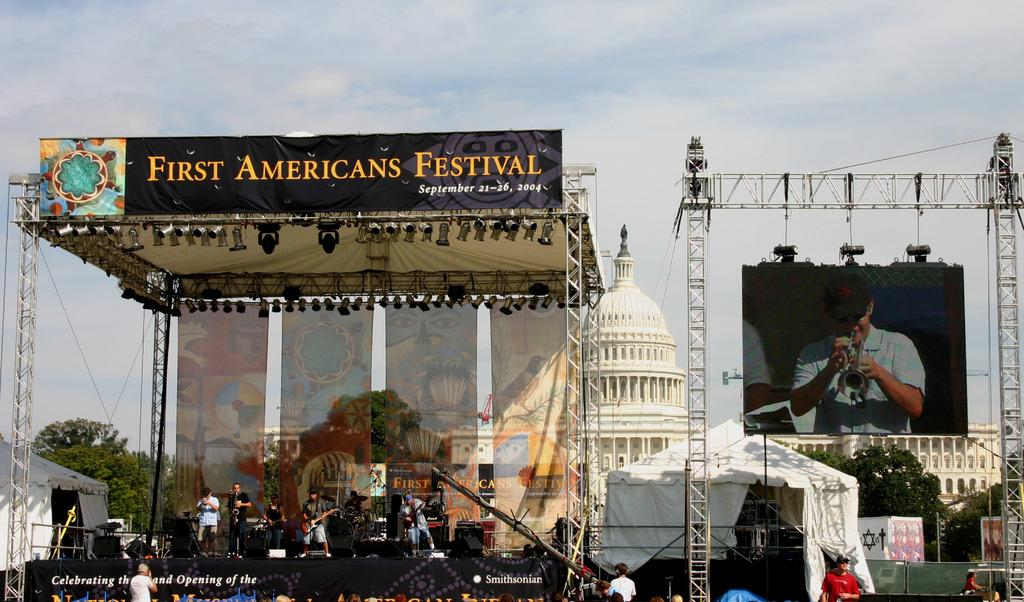<image>
Describe the image concisely. A stage with a First American Festival banner on top of it in fron of the U.S. Capitol. 